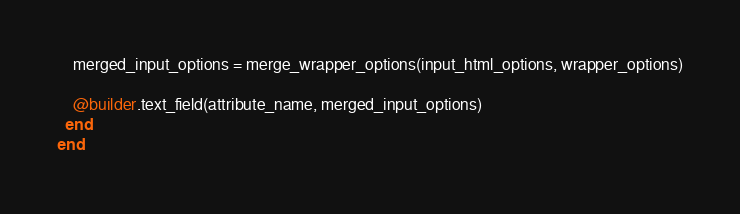<code> <loc_0><loc_0><loc_500><loc_500><_Ruby_>
    merged_input_options = merge_wrapper_options(input_html_options, wrapper_options)

    @builder.text_field(attribute_name, merged_input_options)
  end
end
</code> 